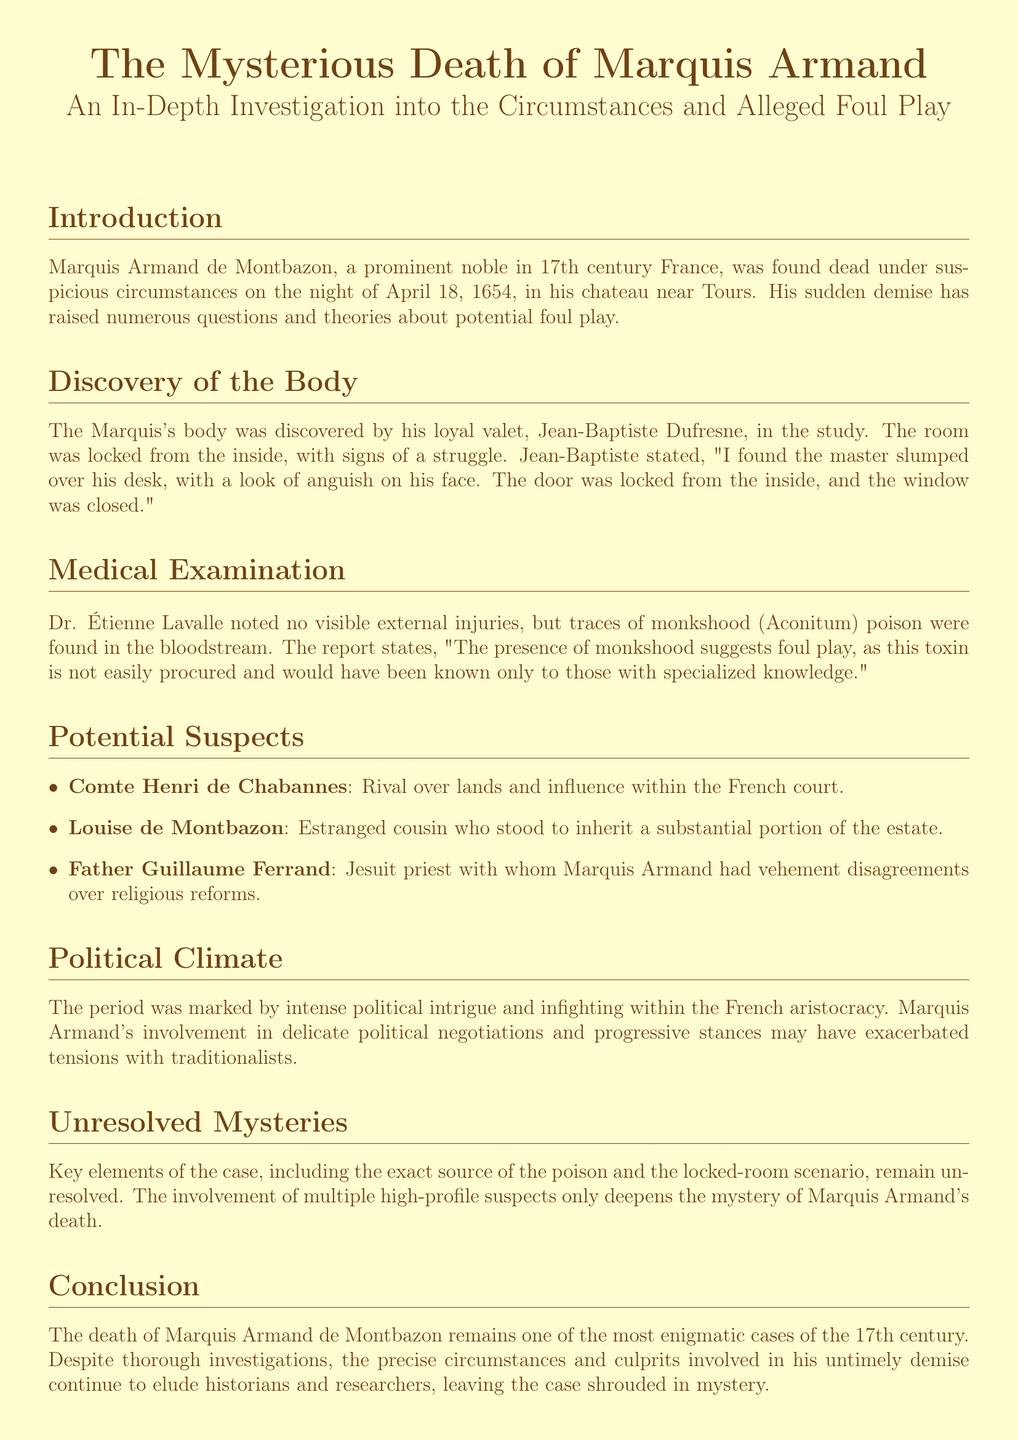What was the date of Marquis Armand's death? The date of death is specified in the document as April 18, 1654.
Answer: April 18, 1654 Who discovered the body of Marquis Armand? The document states that the body was discovered by Jean-Baptiste Dufresne, the valet.
Answer: Jean-Baptiste Dufresne What poison was found in Marquis Armand's bloodstream? The medical examination revealed traces of monkshood (Aconitum) poison.
Answer: monkshood (Aconitum) Who is considered a rival of the Marquis over lands? The document lists Comte Henri de Chabannes as a rival over lands and influence.
Answer: Comte Henri de Chabannes What did Dr. Étienne Lavalle note about external injuries? Dr. Lavalle noted that there were no visible external injuries found on the body.
Answer: no visible external injuries What was unusual about the room where the body was found? The room was noted to be locked from the inside, which raised suspicion.
Answer: locked from the inside Which family member stood to inherit a part of the estate? The estranged cousin, Louise de Montbazon, is mentioned as standing to inherit a portion of the estate.
Answer: Louise de Montbazon What was a potential motive for foul play related to political circumstances? The political climate of intense intrigue and infighting is a backdrop that may suggest motives for foul play.
Answer: political intrigue What role did Father Guillaume Ferrand play in the Marquis's life? Father Ferrand had vehement disagreements with the Marquis over religious reforms.
Answer: vehement disagreements 